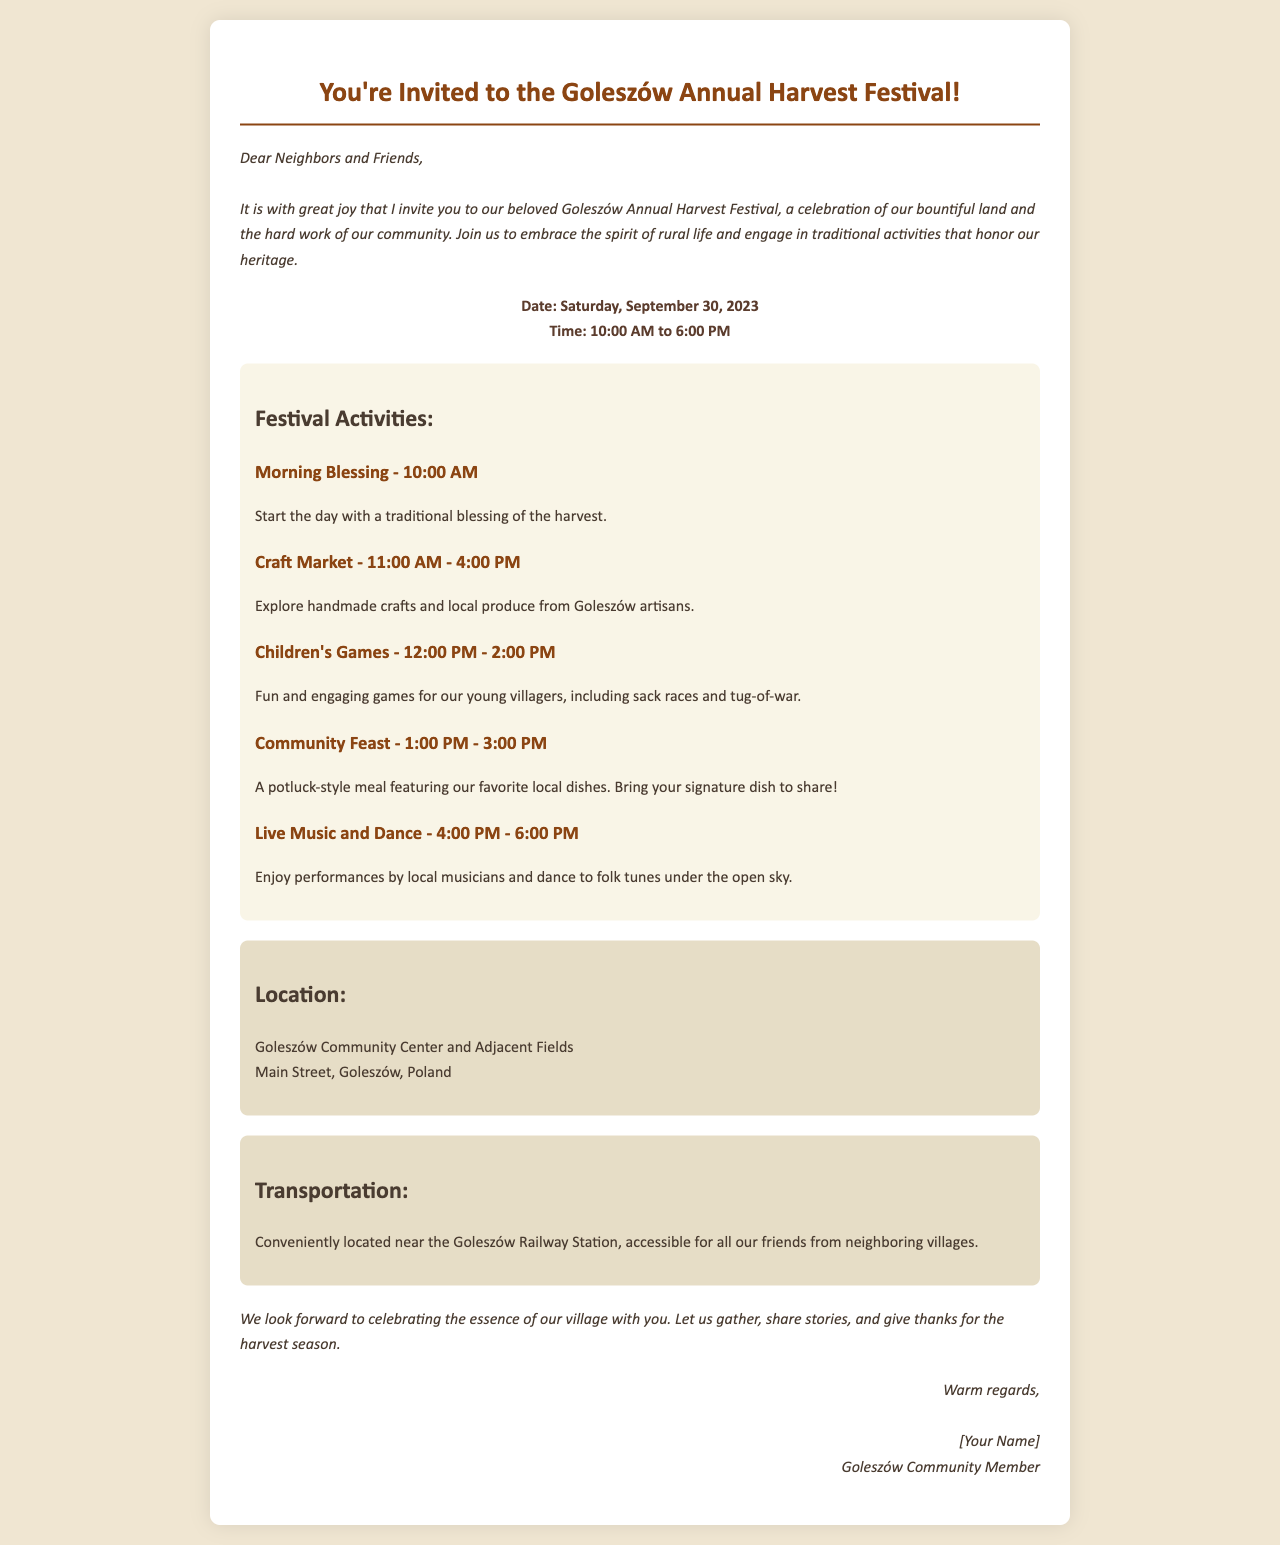What is the date of the festival? The date of the festival is mentioned in the document as Saturday, September 30, 2023.
Answer: Saturday, September 30, 2023 What time does the Children's Games start? The Children's Games are scheduled to start at 12:00 PM according to the activities listed in the document.
Answer: 12:00 PM Where is the festival taking place? The location of the festival is specified as Goleszów Community Center and Adjacent Fields in the document.
Answer: Goleszów Community Center and Adjacent Fields What type of meal is featured in the Community Feast? The type of meal is described as a potluck-style meal in the document.
Answer: Potluck-style meal What is the last activity of the festival? The last activity listed in the document is Live Music and Dance, which occurs from 4:00 PM to 6:00 PM.
Answer: Live Music and Dance How long does the Craft Market last? The Craft Market's duration is indicated to be from 11:00 AM to 4:00 PM, which is a total of 5 hours.
Answer: 5 hours What are participants encouraged to bring for the Community Feast? Participants are encouraged to bring their signature dish to share during the Community Feast as stated in the document.
Answer: Signature dish Which railway station is mentioned in the invitation? The invitation specifies the Goleszów Railway Station for transportation information.
Answer: Goleszów Railway Station Who is the sender of the invitation? The sender is identified simply as a Goleszów Community Member at the end of the document.
Answer: [Your Name] 